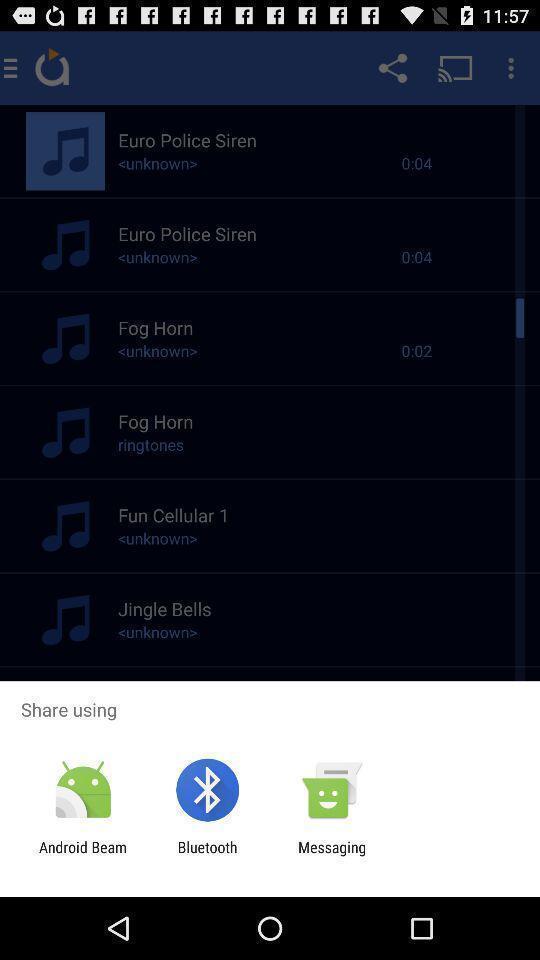Provide a textual representation of this image. Screen shows share option with multiple applications. 